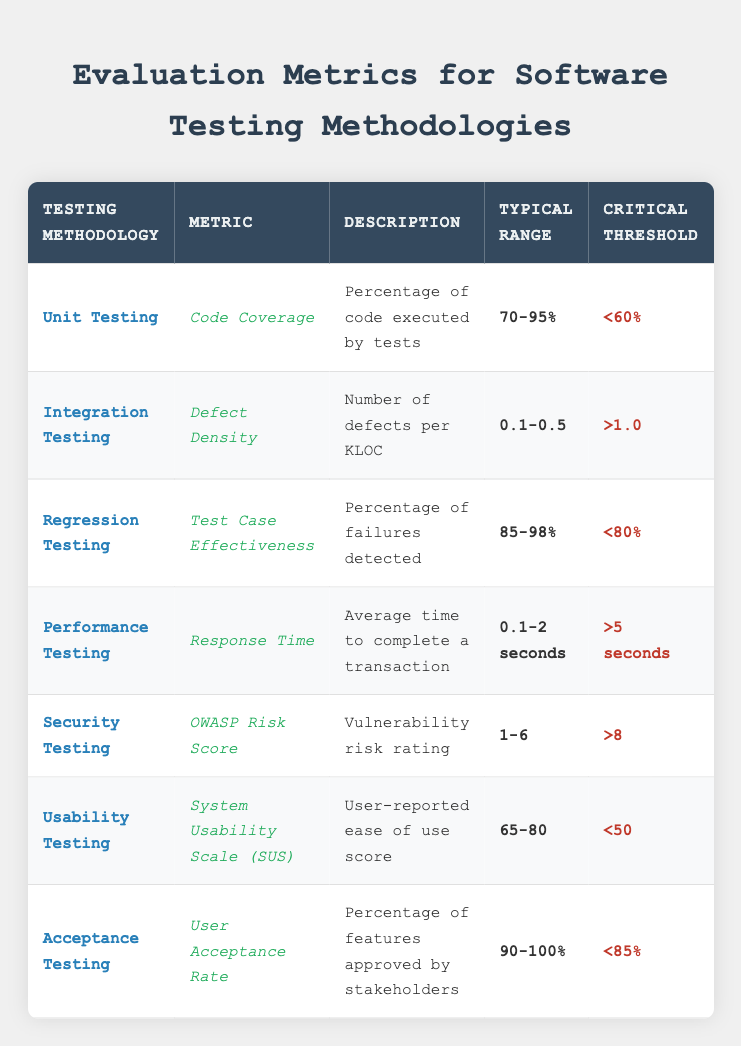What is the typical range for Code Coverage in Unit Testing? The table specifies that the typical range for Code Coverage in Unit Testing is '70-95%'. This value can be found directly under the "Typical Range" column corresponding to the "Unit Testing" row.
Answer: 70-95% What metric is used for Integration Testing? According to the table, the metric used for Integration Testing is "Defect Density". This is located in the second row under the "Metric" column.
Answer: Defect Density Is the Critical Threshold for Regression Testing higher or lower than 80%? The table states that the Critical Threshold for Regression Testing is '<80%'. Since this is a less than value, it indicates the threshold is lower than 80%.
Answer: Lower What is the average of the typical ranges for User Acceptance Rate and Defect Density? The typical ranges for User Acceptance Rate (90-100%) and Defect Density (0.1-0.5) need to be interpreted numerically. Taking the average of 90% and 100% gives 95%, and for Defect Density, the average of 0.1 and 0.5 gives 0.3. Thus, the average for both is (95 + 0.3) / 2 = 47.15 when considering both metrics.
Answer: 47.15 Does Security Testing have a typical range that overlaps with Usability Testing? Security Testing has a typical range of '1-6', while Usability Testing has '65-80'. Since the two ranges do not share any common values, the overlap does not exist, making the answer no.
Answer: No What is the comparison of the Critical Thresholds for Performance Testing and Security Testing? From the table, the Critical Threshold for Performance Testing is '>5 seconds' and for Security Testing it is '>8'. Both thresholds indicate limits that exceed certain high values, and since '8 seconds' is greater than '5 seconds', it can be concluded that the Critical Threshold for Security Testing is higher.
Answer: Higher What percentage of failures detected is considered effective for Regression Testing? The table indicates that for Regression Testing, '85-98%' is considered the typical range for the percentage of failures detected. This value can be directly located under the "Typical Range" column relevant to the "Regression Testing" row.
Answer: 85-98% Which testing methodology has the highest typical range for Code Coverage? The row for Unit Testing specifies a typical range of '70-95%'. Since Code Coverage is specifically mentioned only for Unit Testing, it implies that Unit Testing is the methodology with the highest typical range for this metric.
Answer: Unit Testing 